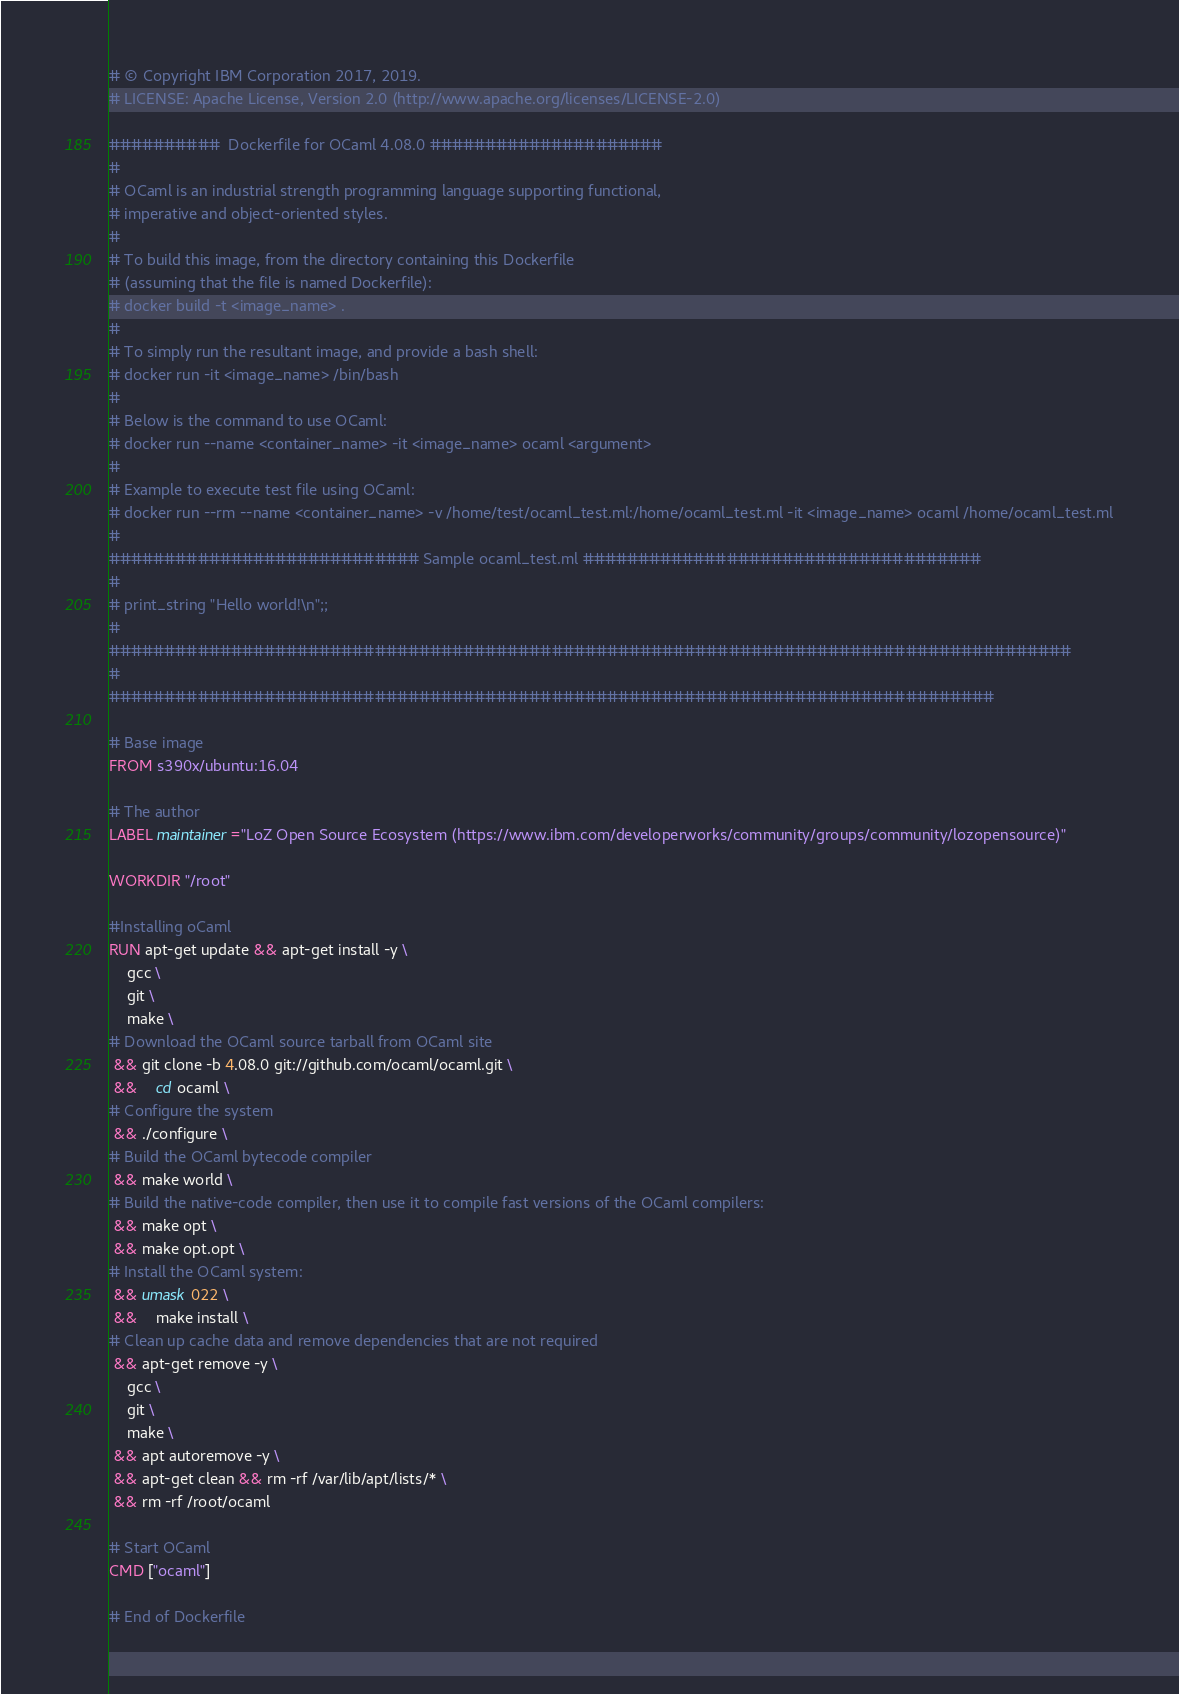Convert code to text. <code><loc_0><loc_0><loc_500><loc_500><_Dockerfile_># © Copyright IBM Corporation 2017, 2019.
# LICENSE: Apache License, Version 2.0 (http://www.apache.org/licenses/LICENSE-2.0)

##########  Dockerfile for OCaml 4.08.0 #####################
#
# OCaml is an industrial strength programming language supporting functional, 
# imperative and object-oriented styles.
#
# To build this image, from the directory containing this Dockerfile
# (assuming that the file is named Dockerfile):
# docker build -t <image_name> .
#
# To simply run the resultant image, and provide a bash shell:
# docker run -it <image_name> /bin/bash
#
# Below is the command to use OCaml:
# docker run --name <container_name> -it <image_name> ocaml <argument>
#
# Example to execute test file using OCaml:
# docker run --rm --name <container_name> -v /home/test/ocaml_test.ml:/home/ocaml_test.ml -it <image_name> ocaml /home/ocaml_test.ml
#
############################ Sample ocaml_test.ml ####################################
#
# print_string "Hello world!\n";;
#
#######################################################################################
#
################################################################################

# Base image
FROM s390x/ubuntu:16.04

# The author
LABEL maintainer="LoZ Open Source Ecosystem (https://www.ibm.com/developerworks/community/groups/community/lozopensource)"

WORKDIR "/root"

#Installing oCaml
RUN apt-get update && apt-get install -y \
    gcc \
	git \
	make \    
# Download the OCaml source tarball from OCaml site
 && git clone -b 4.08.0 git://github.com/ocaml/ocaml.git \
 &&	cd ocaml \    
# Configure the system
 && ./configure \    
# Build the OCaml bytecode compiler
 && make world \    
# Build the native-code compiler, then use it to compile fast versions of the OCaml compilers:
 && make opt \
 && make opt.opt \    
# Install the OCaml system:
 && umask 022 \
 &&	make install \    
# Clean up cache data and remove dependencies that are not required
 && apt-get remove -y \
    gcc \
	git \
	make \
 && apt autoremove -y \
 && apt-get clean && rm -rf /var/lib/apt/lists/* \
 && rm -rf /root/ocaml

# Start OCaml
CMD ["ocaml"]
         
# End of Dockerfile
</code> 